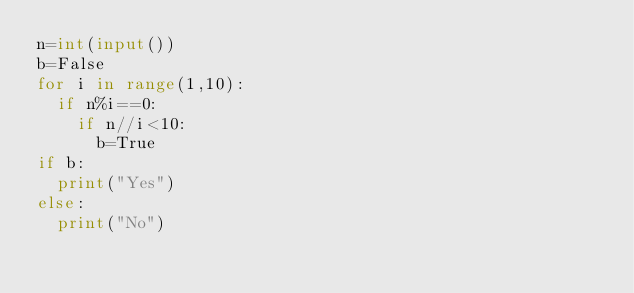Convert code to text. <code><loc_0><loc_0><loc_500><loc_500><_Python_>n=int(input())
b=False
for i in range(1,10):
  if n%i==0:
    if n//i<10:
      b=True
if b:
  print("Yes")
else:
  print("No")</code> 